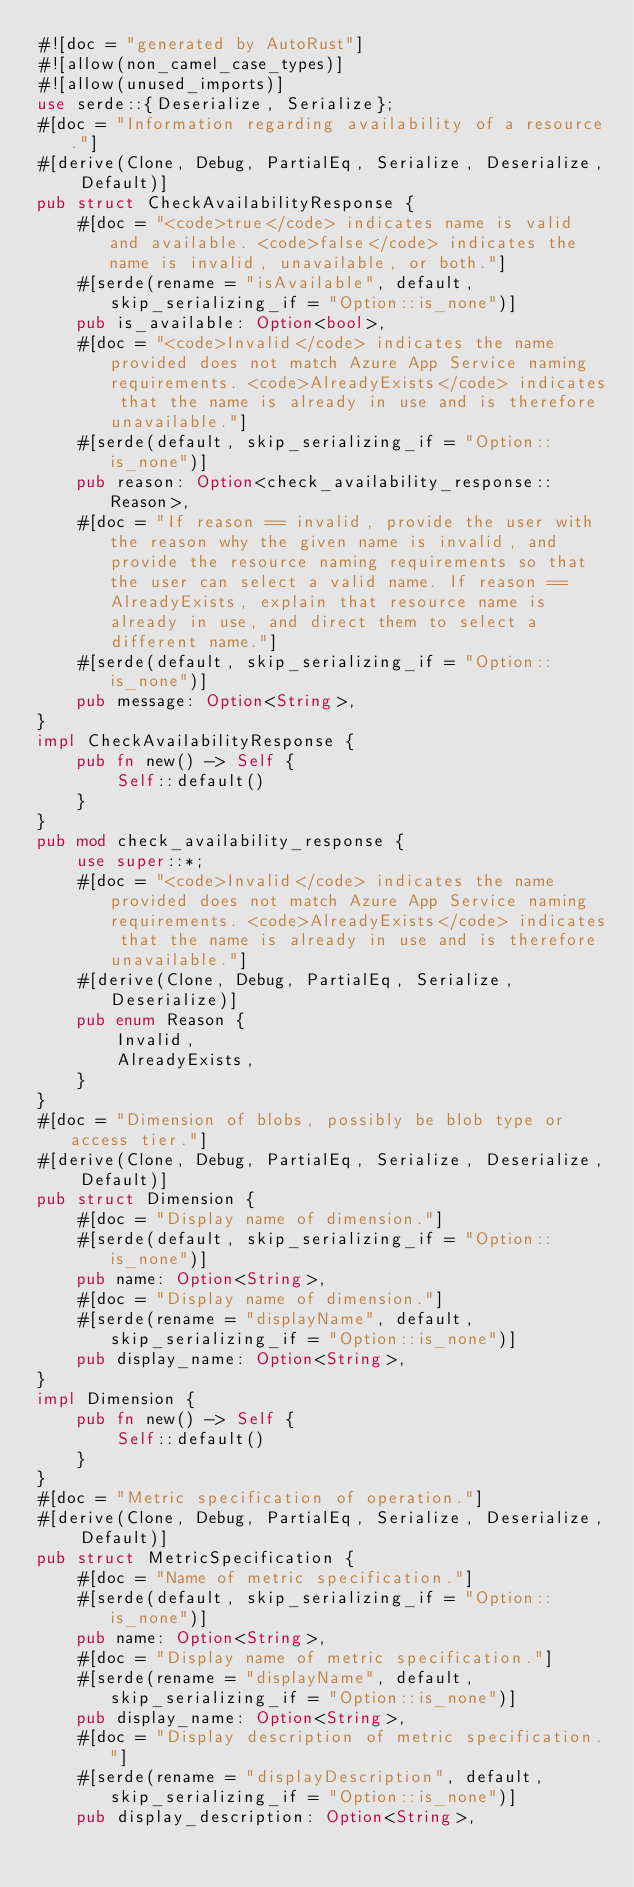<code> <loc_0><loc_0><loc_500><loc_500><_Rust_>#![doc = "generated by AutoRust"]
#![allow(non_camel_case_types)]
#![allow(unused_imports)]
use serde::{Deserialize, Serialize};
#[doc = "Information regarding availability of a resource."]
#[derive(Clone, Debug, PartialEq, Serialize, Deserialize, Default)]
pub struct CheckAvailabilityResponse {
    #[doc = "<code>true</code> indicates name is valid and available. <code>false</code> indicates the name is invalid, unavailable, or both."]
    #[serde(rename = "isAvailable", default, skip_serializing_if = "Option::is_none")]
    pub is_available: Option<bool>,
    #[doc = "<code>Invalid</code> indicates the name provided does not match Azure App Service naming requirements. <code>AlreadyExists</code> indicates that the name is already in use and is therefore unavailable."]
    #[serde(default, skip_serializing_if = "Option::is_none")]
    pub reason: Option<check_availability_response::Reason>,
    #[doc = "If reason == invalid, provide the user with the reason why the given name is invalid, and provide the resource naming requirements so that the user can select a valid name. If reason == AlreadyExists, explain that resource name is already in use, and direct them to select a different name."]
    #[serde(default, skip_serializing_if = "Option::is_none")]
    pub message: Option<String>,
}
impl CheckAvailabilityResponse {
    pub fn new() -> Self {
        Self::default()
    }
}
pub mod check_availability_response {
    use super::*;
    #[doc = "<code>Invalid</code> indicates the name provided does not match Azure App Service naming requirements. <code>AlreadyExists</code> indicates that the name is already in use and is therefore unavailable."]
    #[derive(Clone, Debug, PartialEq, Serialize, Deserialize)]
    pub enum Reason {
        Invalid,
        AlreadyExists,
    }
}
#[doc = "Dimension of blobs, possibly be blob type or access tier."]
#[derive(Clone, Debug, PartialEq, Serialize, Deserialize, Default)]
pub struct Dimension {
    #[doc = "Display name of dimension."]
    #[serde(default, skip_serializing_if = "Option::is_none")]
    pub name: Option<String>,
    #[doc = "Display name of dimension."]
    #[serde(rename = "displayName", default, skip_serializing_if = "Option::is_none")]
    pub display_name: Option<String>,
}
impl Dimension {
    pub fn new() -> Self {
        Self::default()
    }
}
#[doc = "Metric specification of operation."]
#[derive(Clone, Debug, PartialEq, Serialize, Deserialize, Default)]
pub struct MetricSpecification {
    #[doc = "Name of metric specification."]
    #[serde(default, skip_serializing_if = "Option::is_none")]
    pub name: Option<String>,
    #[doc = "Display name of metric specification."]
    #[serde(rename = "displayName", default, skip_serializing_if = "Option::is_none")]
    pub display_name: Option<String>,
    #[doc = "Display description of metric specification."]
    #[serde(rename = "displayDescription", default, skip_serializing_if = "Option::is_none")]
    pub display_description: Option<String>,</code> 